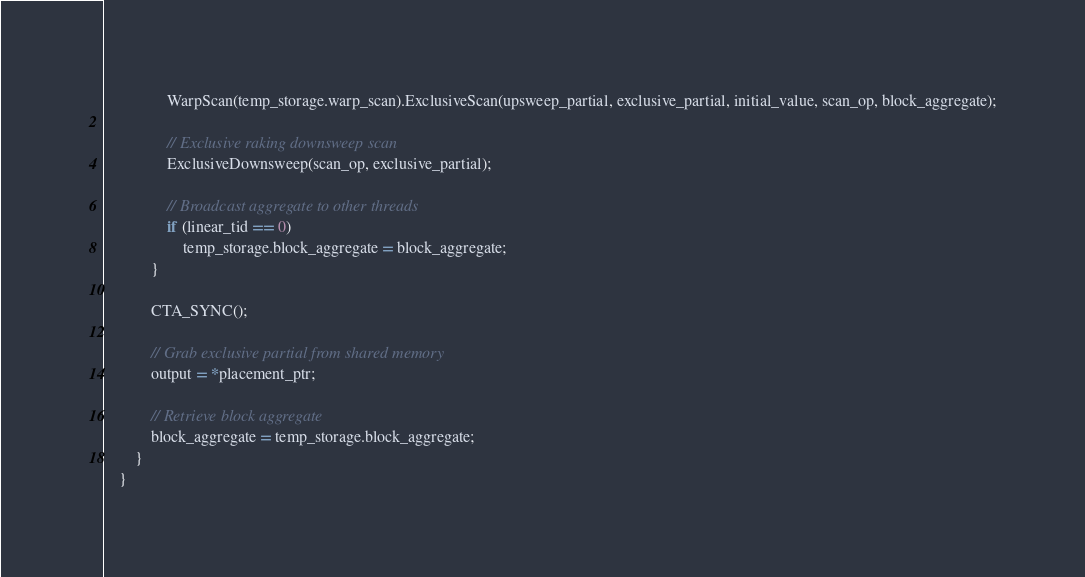<code> <loc_0><loc_0><loc_500><loc_500><_Cuda_>                WarpScan(temp_storage.warp_scan).ExclusiveScan(upsweep_partial, exclusive_partial, initial_value, scan_op, block_aggregate);

                // Exclusive raking downsweep scan
                ExclusiveDownsweep(scan_op, exclusive_partial);

                // Broadcast aggregate to other threads
                if (linear_tid == 0)
                    temp_storage.block_aggregate = block_aggregate;
            }

            CTA_SYNC();

            // Grab exclusive partial from shared memory
            output = *placement_ptr;

            // Retrieve block aggregate
            block_aggregate = temp_storage.block_aggregate;
        }
    }

</code> 